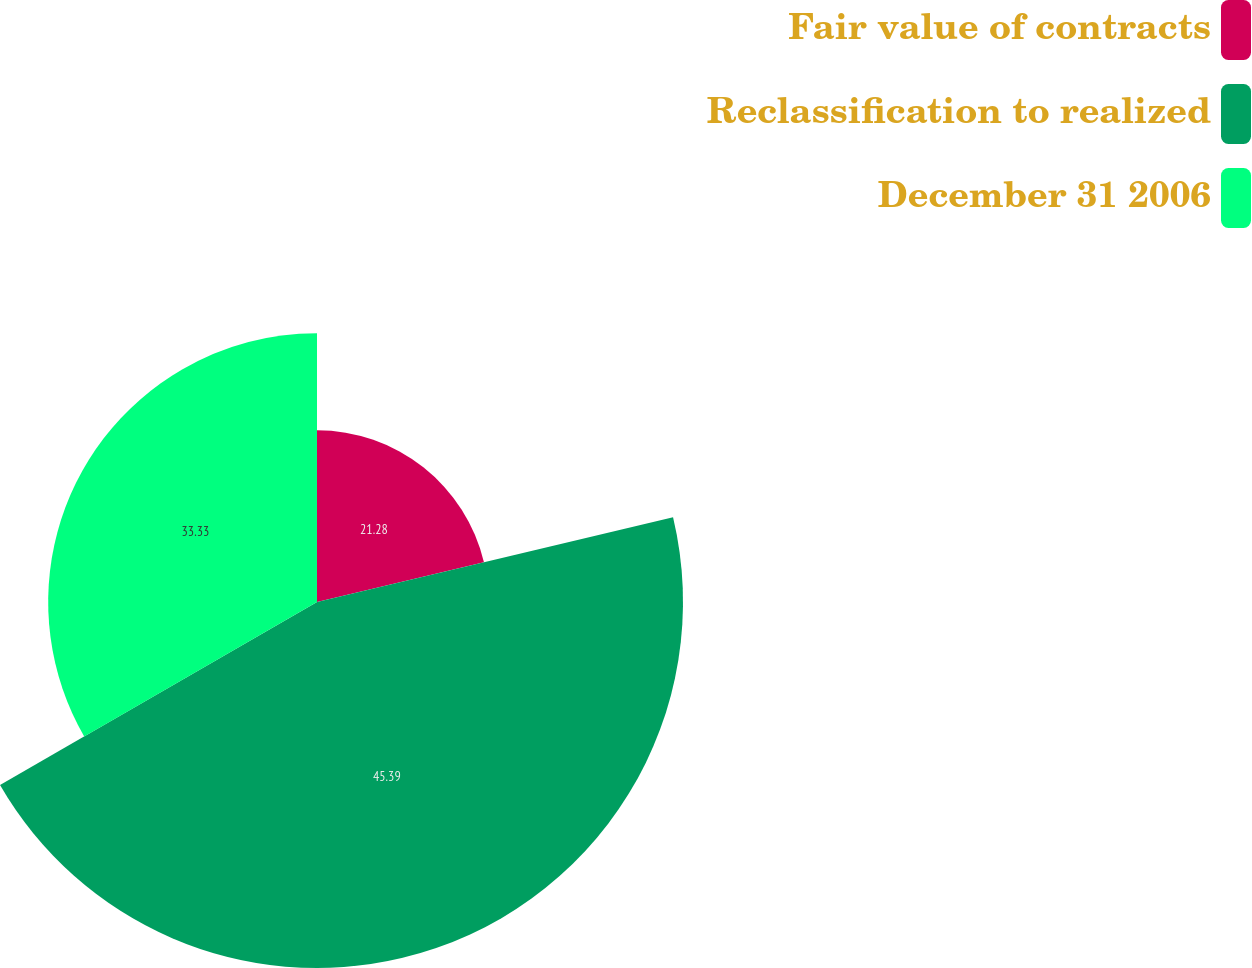Convert chart. <chart><loc_0><loc_0><loc_500><loc_500><pie_chart><fcel>Fair value of contracts<fcel>Reclassification to realized<fcel>December 31 2006<nl><fcel>21.28%<fcel>45.38%<fcel>33.33%<nl></chart> 